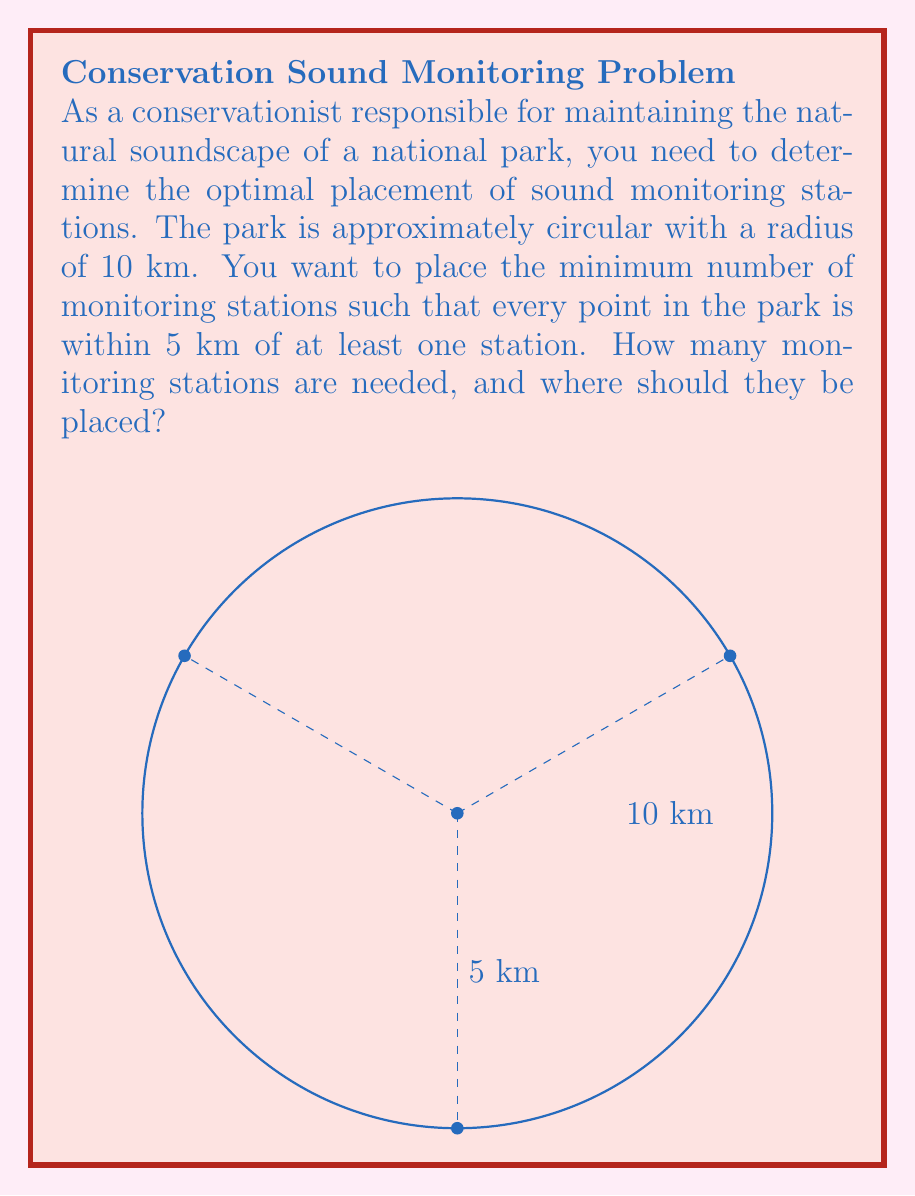Help me with this question. To solve this problem, we can use the concept of circle packing within a larger circle. Each monitoring station covers a circular area with a radius of 5 km, and we need to pack these smaller circles within the larger 10 km radius park circle.

Step 1: Calculate the area of the park.
$A_{park} = \pi r^2 = \pi (10 \text{ km})^2 = 100\pi \text{ km}^2$

Step 2: Calculate the area covered by each monitoring station.
$A_{station} = \pi r^2 = \pi (5 \text{ km})^2 = 25\pi \text{ km}^2$

Step 3: Estimate the number of stations needed by dividing the park area by the station coverage area.
$N_{estimate} = \frac{A_{park}}{A_{station}} = \frac{100\pi}{25\pi} = 4$

However, this estimate doesn't account for overlaps and uncovered areas near the park's boundary.

Step 4: Determine the optimal arrangement.
The most efficient packing for circles is a hexagonal arrangement. In this case, we can place three monitoring stations in an equilateral triangle formation, with each station 5√3 km (≈ 8.66 km) from the park's center and 10 km from each other. A fourth station is needed at the center to cover the middle area.

Step 5: Verify coverage.
This arrangement ensures that every point in the park is within 5 km of at least one station. The three outer stations cover the entire circumference of the park, while the central station fills the gap in the middle.

The coordinates of the stations in kilometers, with (0,0) as the park center, are:
1. (0, 0)
2. (5√3, 5) ≈ (8.66, 5)
3. (-5√3, 5) ≈ (-8.66, 5)
4. (0, -10)
Answer: 4 stations at (0,0), (5√3,5), (-5√3,5), and (0,-10) km from the park center. 